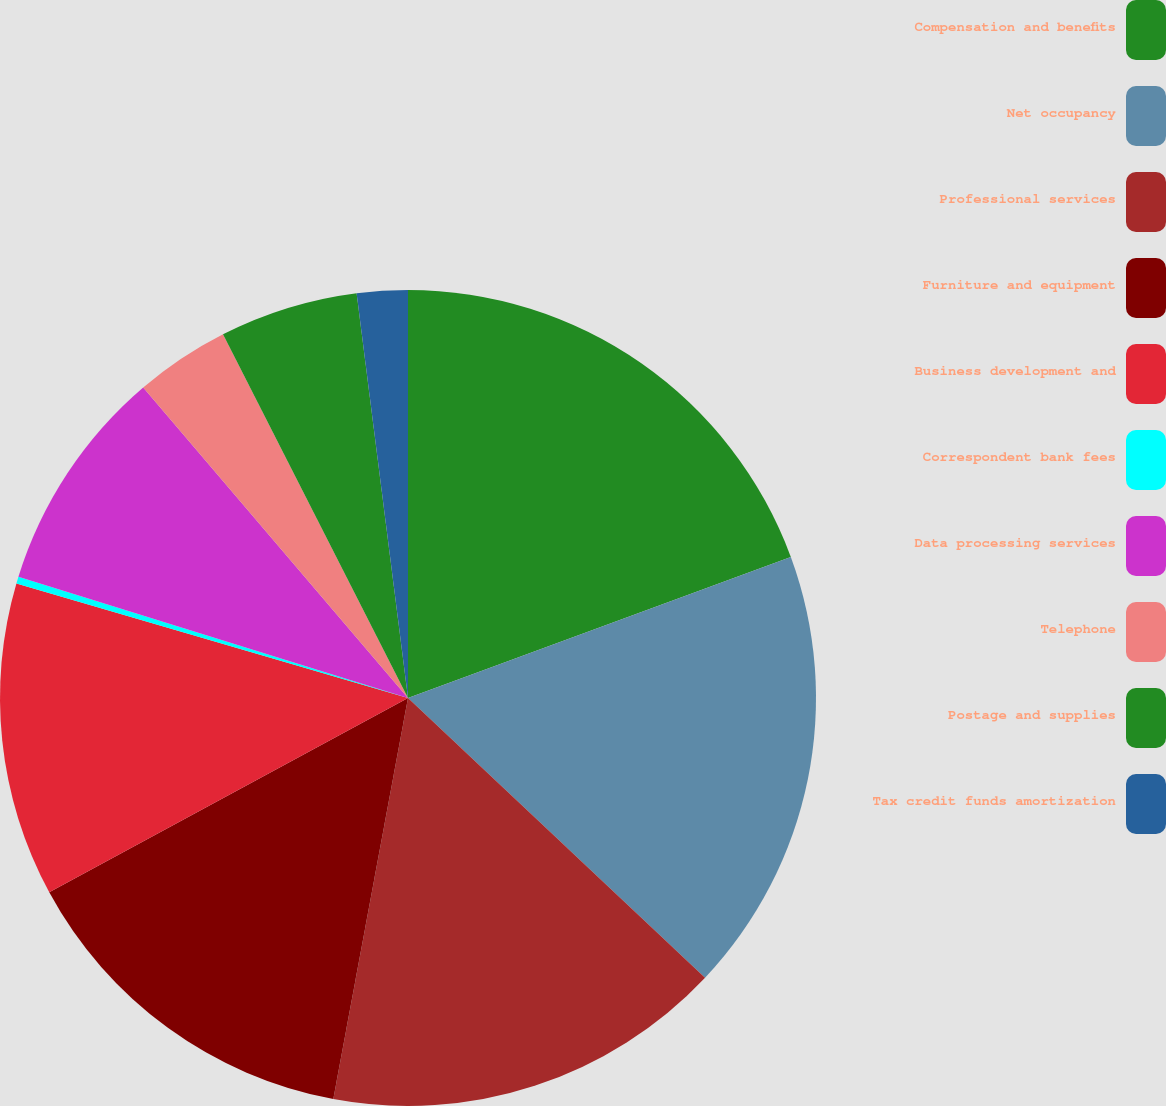<chart> <loc_0><loc_0><loc_500><loc_500><pie_chart><fcel>Compensation and benefits<fcel>Net occupancy<fcel>Professional services<fcel>Furniture and equipment<fcel>Business development and<fcel>Correspondent bank fees<fcel>Data processing services<fcel>Telephone<fcel>Postage and supplies<fcel>Tax credit funds amortization<nl><fcel>19.38%<fcel>17.64%<fcel>15.91%<fcel>14.17%<fcel>12.43%<fcel>0.27%<fcel>8.96%<fcel>3.75%<fcel>5.48%<fcel>2.01%<nl></chart> 